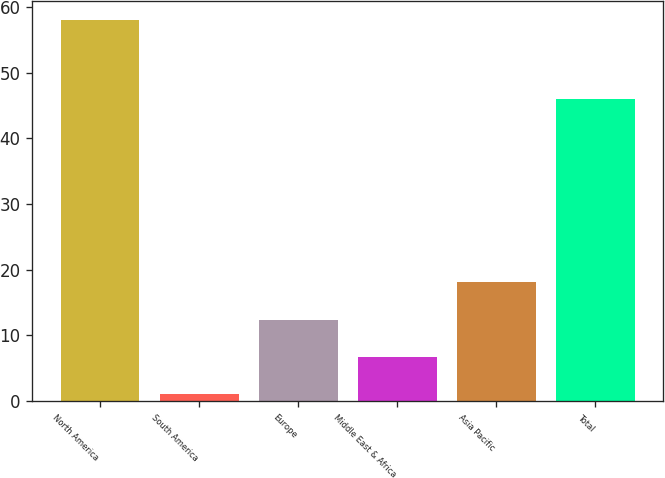<chart> <loc_0><loc_0><loc_500><loc_500><bar_chart><fcel>North America<fcel>South America<fcel>Europe<fcel>Middle East & Africa<fcel>Asia Pacific<fcel>Total<nl><fcel>58<fcel>1<fcel>12.4<fcel>6.7<fcel>18.1<fcel>46<nl></chart> 